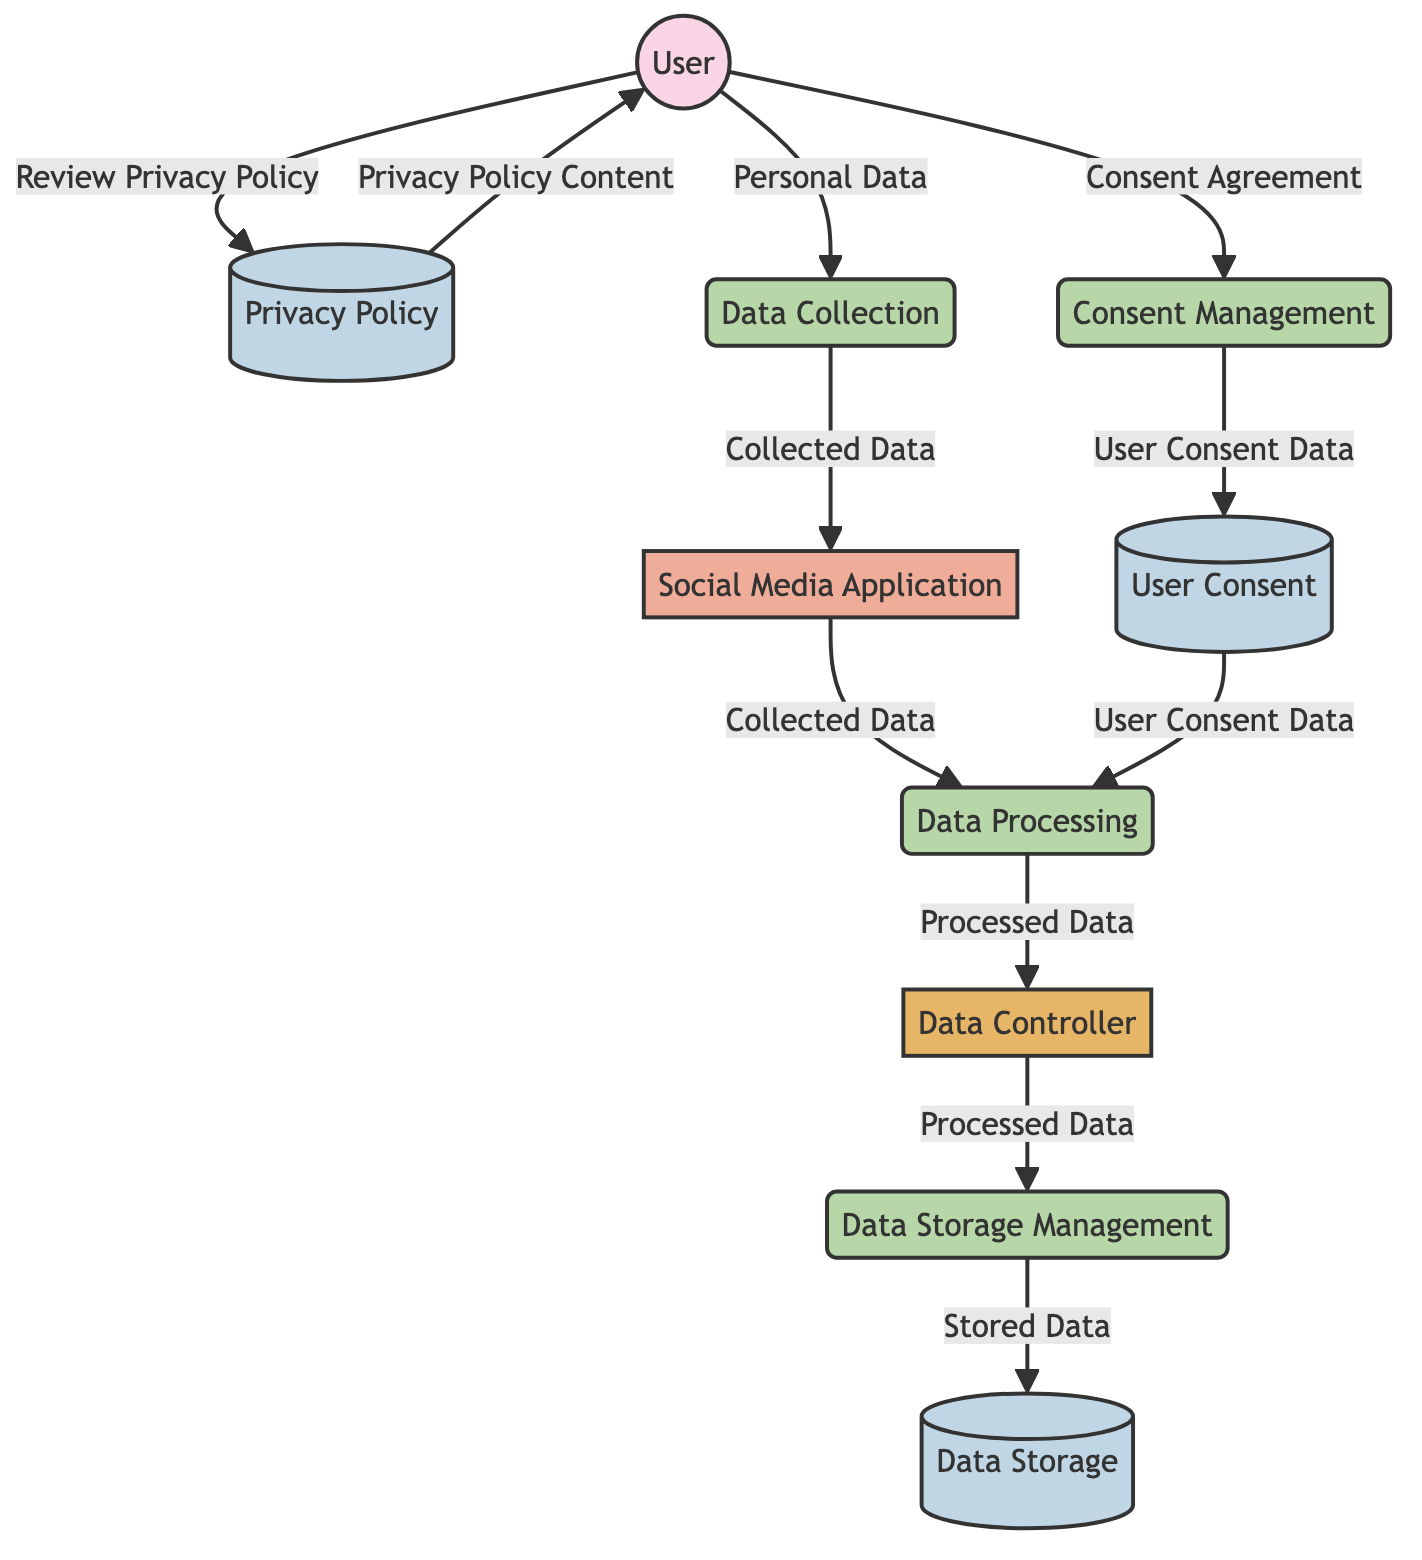What is the input to the Data Collection process? The input to the Data Collection process is the User, as indicated by the arrow connecting the User to the Data Collection node.
Answer: User What type of entity is the Data Controller? The Data Controller is labeled as an Internal Entity in the diagram, which classifies its role within the data flow system.
Answer: Internal Entity How many data stores are present in the diagram? There are three data stores identified in the diagram: Privacy Policy, User Consent, and Data Storage.
Answer: 3 What data is sent from the User to the Privacy Policy? The User sends the data labeled as "Review Privacy Policy" to the Privacy Policy, as shown by the arrow and corresponding label in the diagram.
Answer: Review Privacy Policy What process manages the User Consent data? The process that manages the User Consent data is the Consent Management process, which receives input from the User and the Privacy Policy.
Answer: Consent Management What is the output of the Data Processing process? The output of the Data Processing process is the Data Controller, which receives Collected Data from the Social Media Application and User Consent data.
Answer: Data Controller Which entity receives the Processed Data? The entity that receives the Processed Data is the Data Storage Management, as indicated by the arrow leading from the Data Controller to this process.
Answer: Data Storage Management What flow contains the Privacy Policy Content? The flow that contains the Privacy Policy Content goes from the Privacy Policy to the User, which implies that the User receives the content as part of the consent process.
Answer: Privacy Policy Content Which external entity provides Personal Data to the Data Collection process? The external entity that provides Personal Data to the Data Collection process is the User, as represented by the arrow indicating the flow of Personal Data into the process.
Answer: User 